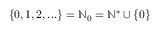<formula> <loc_0><loc_0><loc_500><loc_500>\, \{ 0 , 1 , 2 , \dots \} = \mathbb { N } _ { 0 } = \mathbb { N } ^ { * } \cup \{ 0 \}</formula> 